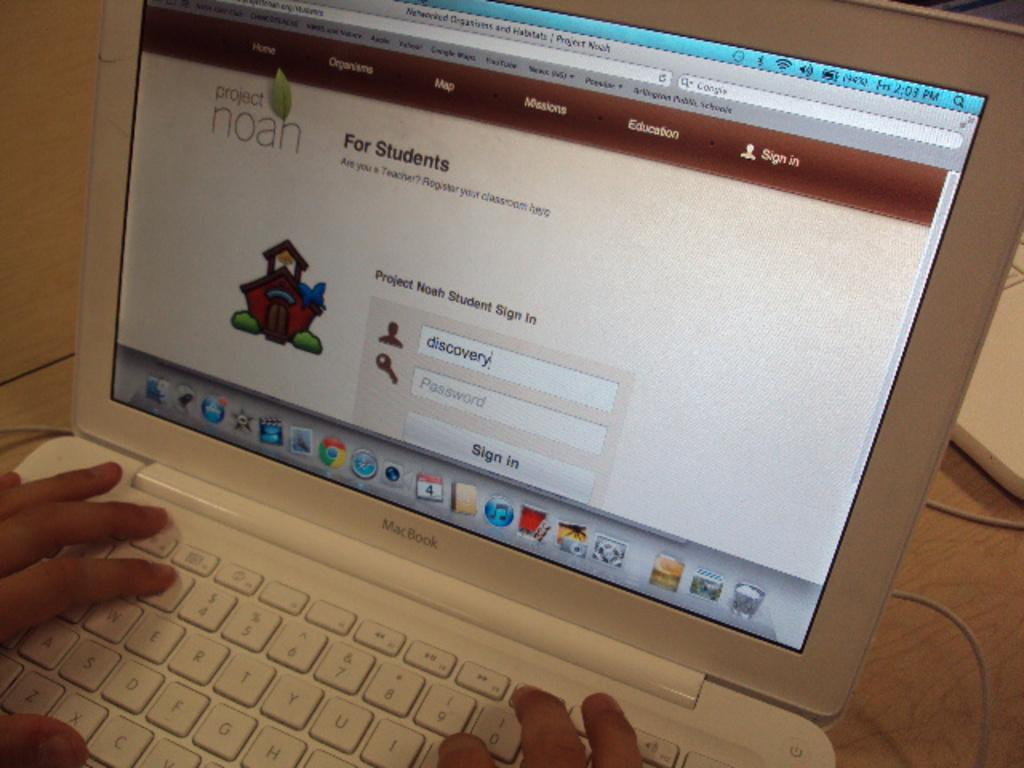<image>
Write a terse but informative summary of the picture. A Mac Book laptop on a web page for students 